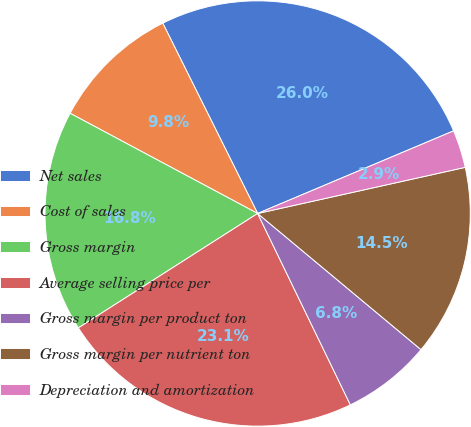Convert chart to OTSL. <chart><loc_0><loc_0><loc_500><loc_500><pie_chart><fcel>Net sales<fcel>Cost of sales<fcel>Gross margin<fcel>Average selling price per<fcel>Gross margin per product ton<fcel>Gross margin per nutrient ton<fcel>Depreciation and amortization<nl><fcel>26.01%<fcel>9.83%<fcel>16.85%<fcel>23.14%<fcel>6.76%<fcel>14.54%<fcel>2.87%<nl></chart> 